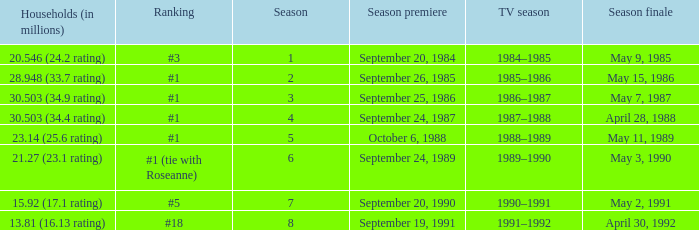Which TV season has a Season smaller than 8, and a Household (in millions) of 15.92 (17.1 rating)? 1990–1991. 